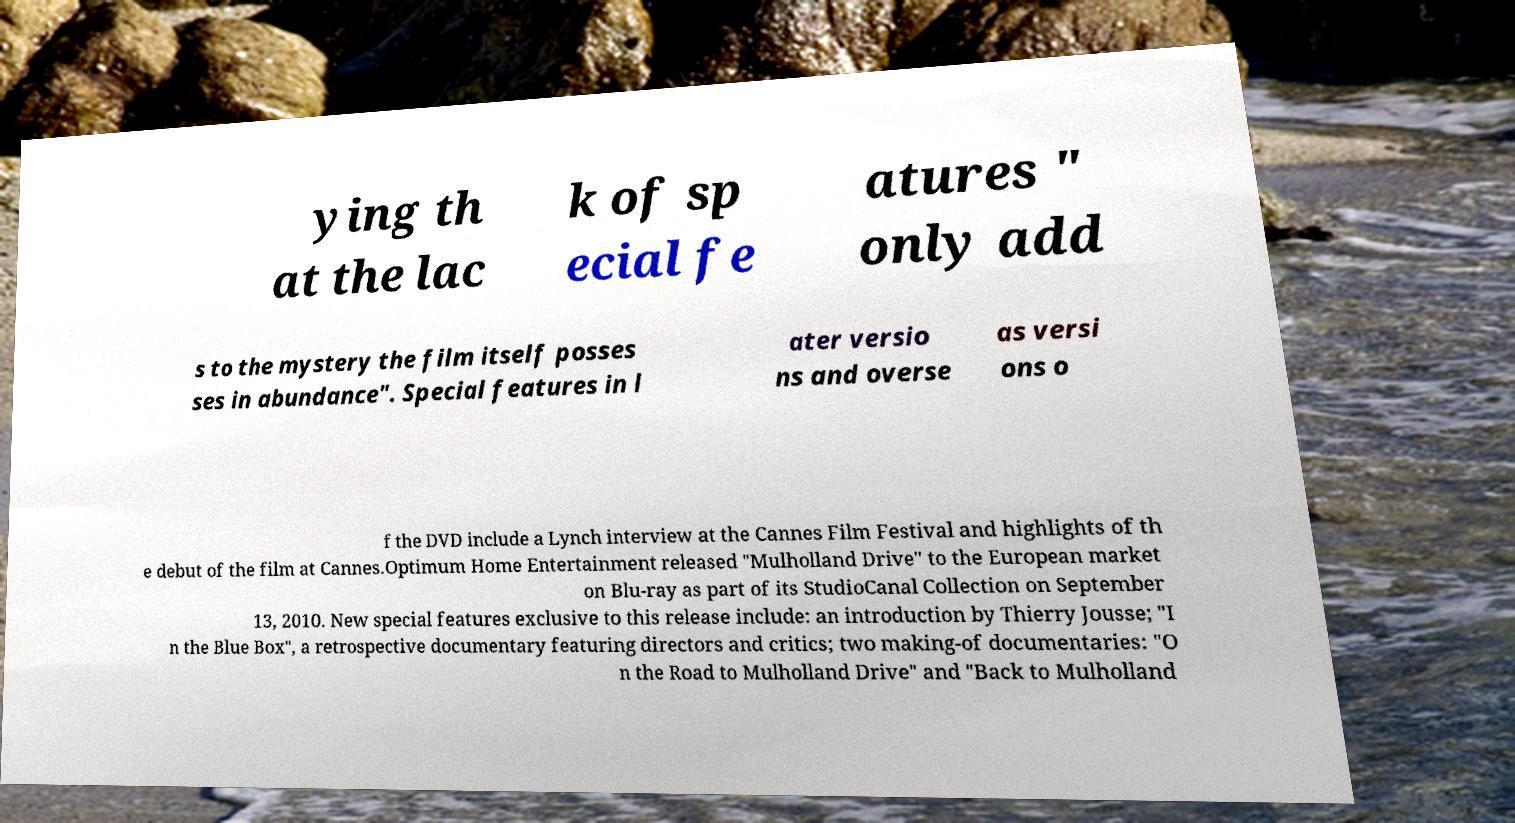Please identify and transcribe the text found in this image. ying th at the lac k of sp ecial fe atures " only add s to the mystery the film itself posses ses in abundance". Special features in l ater versio ns and overse as versi ons o f the DVD include a Lynch interview at the Cannes Film Festival and highlights of th e debut of the film at Cannes.Optimum Home Entertainment released "Mulholland Drive" to the European market on Blu-ray as part of its StudioCanal Collection on September 13, 2010. New special features exclusive to this release include: an introduction by Thierry Jousse; "I n the Blue Box", a retrospective documentary featuring directors and critics; two making-of documentaries: "O n the Road to Mulholland Drive" and "Back to Mulholland 